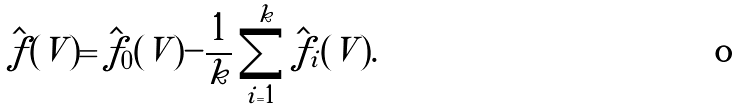Convert formula to latex. <formula><loc_0><loc_0><loc_500><loc_500>\hat { f } ( V ) = \hat { f } _ { 0 } ( V ) - \frac { 1 } { k } \sum _ { i = 1 } ^ { k } \hat { f } _ { i } ( V ) .</formula> 